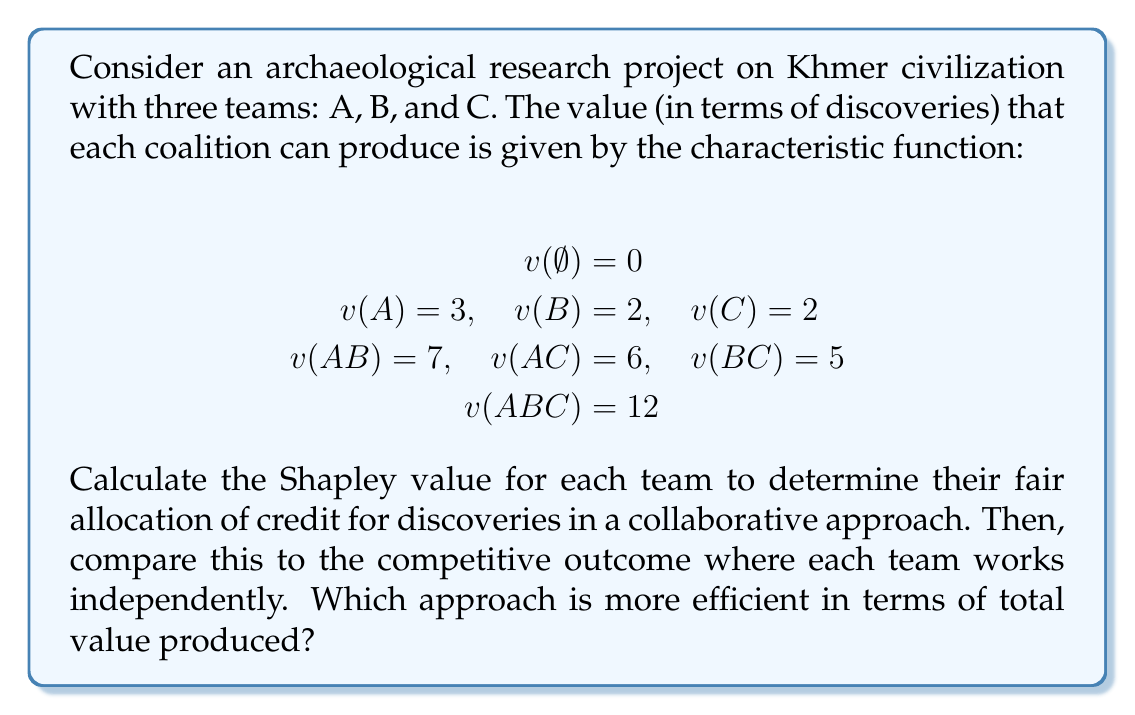What is the answer to this math problem? To solve this problem, we'll use cooperative game theory, specifically the Shapley value, to analyze the collaborative approach. Then we'll compare it to the competitive approach.

1. Calculate the Shapley value for each team:

The Shapley value formula for player i is:
$$\phi_i(v) = \sum_{S \subseteq N \setminus \{i\}} \frac{|S|!(n-|S|-1)!}{n!}[v(S \cup \{i\}) - v(S)]$$

For Team A:
$$\phi_A = \frac{1}{3}[v(A) - v(\emptyset)] + \frac{1}{6}[v(AB) - v(B)] + \frac{1}{6}[v(AC) - v(C)] + \frac{1}{3}[v(ABC) - v(BC)]$$
$$\phi_A = \frac{1}{3}[3 - 0] + \frac{1}{6}[7 - 2] + \frac{1}{6}[6 - 2] + \frac{1}{3}[12 - 5] = 1 + \frac{5}{6} + \frac{2}{3} + \frac{7}{3} = 4.5$$

For Team B:
$$\phi_B = \frac{1}{3}[v(B) - v(\emptyset)] + \frac{1}{6}[v(AB) - v(A)] + \frac{1}{6}[v(BC) - v(C)] + \frac{1}{3}[v(ABC) - v(AC)]$$
$$\phi_B = \frac{1}{3}[2 - 0] + \frac{1}{6}[7 - 3] + \frac{1}{6}[5 - 2] + \frac{1}{3}[12 - 6] = \frac{2}{3} + \frac{2}{3} + \frac{1}{2} + 2 = 3.8333$$

For Team C:
$$\phi_C = \frac{1}{3}[v(C) - v(\emptyset)] + \frac{1}{6}[v(AC) - v(A)] + \frac{1}{6}[v(BC) - v(B)] + \frac{1}{3}[v(ABC) - v(AB)]$$
$$\phi_C = \frac{1}{3}[2 - 0] + \frac{1}{6}[6 - 3] + \frac{1}{6}[5 - 2] + \frac{1}{3}[12 - 7] = \frac{2}{3} + \frac{1}{2} + \frac{1}{2} + \frac{5}{3} = 3.6667$$

2. Collaborative approach:
Total value produced = $v(ABC) = 12$

3. Competitive approach:
Total value produced = $v(A) + v(B) + v(C) = 3 + 2 + 2 = 7$

4. Efficiency comparison:
The collaborative approach produces a total value of 12, while the competitive approach produces a total value of 7. Therefore, the collaborative approach is more efficient, producing 71.43% more value than the competitive approach.
Answer: The Shapley values for teams A, B, and C are approximately 4.5, 3.8333, and 3.6667, respectively. The collaborative approach is more efficient, producing a total value of 12 compared to 7 in the competitive approach, an increase of 71.43%. 